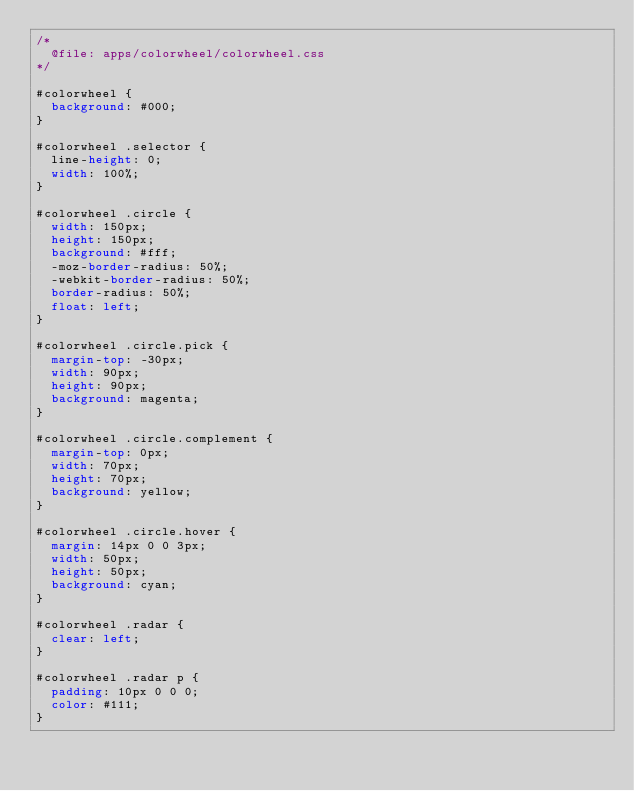<code> <loc_0><loc_0><loc_500><loc_500><_CSS_>/*
	@file: apps/colorwheel/colorwheel.css
*/

#colorwheel {
	background: #000;
}

#colorwheel .selector {
	line-height: 0;
	width: 100%;
}

#colorwheel .circle {
	width: 150px;
	height: 150px;
	background: #fff; 
	-moz-border-radius: 50%;
	-webkit-border-radius: 50%;
	border-radius: 50%;
	float: left;
}

#colorwheel .circle.pick {
	margin-top: -30px;
	width: 90px;
	height: 90px;
	background: magenta; 
}

#colorwheel .circle.complement { 
	margin-top: 0px;
	width: 70px;
	height: 70px;
	background: yellow;
}

#colorwheel .circle.hover { 
	margin: 14px 0 0 3px;
	width: 50px;
	height: 50px;
	background: cyan;
}

#colorwheel .radar {
	clear: left;
}

#colorwheel .radar p {
	padding: 10px 0 0 0;
	color: #111;
}</code> 